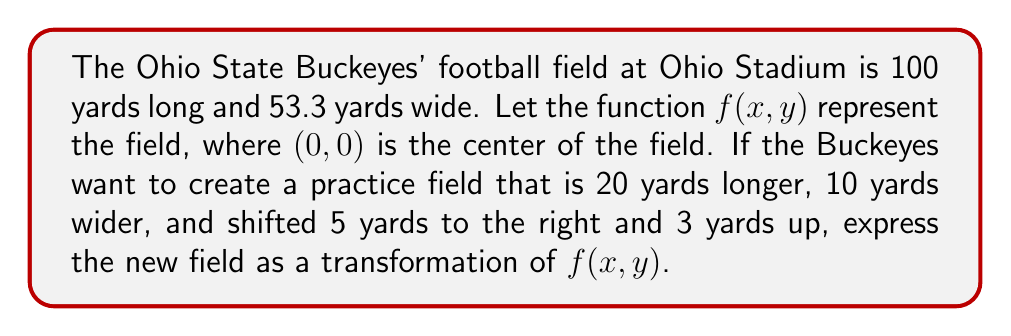Solve this math problem. Let's approach this step-by-step:

1) First, let's identify the transformations we need to apply:
   - Stretch horizontally by 10 yards on each side: multiply x by $(100+20)/100 = 1.2$
   - Stretch vertically by 5 yards on each side: multiply y by $(53.3+10)/53.3 \approx 1.1876$
   - Shift 5 yards right: subtract 5 from x
   - Shift 3 yards up: subtract 3 from y

2) We apply these transformations in the reverse order of how we want them to occur:
   $$g(x,y) = f(\frac{x-5}{1.2}, \frac{y-3}{1.1876})$$

3) Let's break down what this means:
   - $(x-5)$ shifts the field 5 yards to the right
   - $(y-3)$ shifts the field 3 yards up
   - Dividing by 1.2 stretches the field horizontally
   - Dividing by 1.1876 stretches the field vertically

4) This transformation will result in a new field that is:
   - 120 yards long (100 * 1.2)
   - 63.3 yards wide (53.3 * 1.1876)
   - Centered at (5, 3) instead of (0, 0)
Answer: $$g(x,y) = f(\frac{x-5}{1.2}, \frac{y-3}{1.1876})$$ 